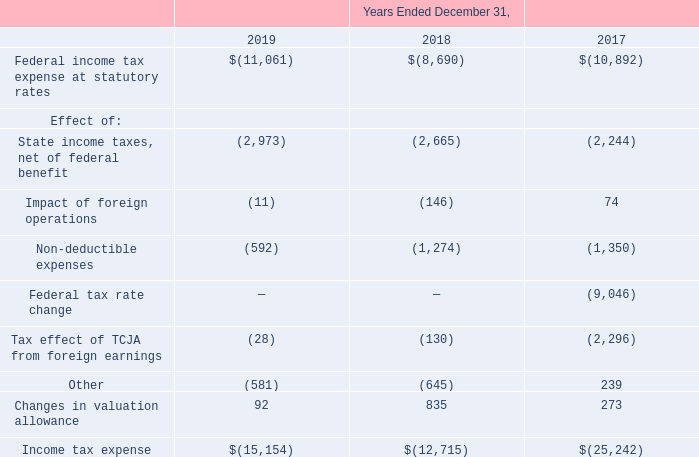5. Income taxes: (Continued)
In the normal course of business the Company takes positions on its tax returns that may be challenged by taxing
authorities. The Company evaluates all uncertain tax positions to assess whether the position will more likely than not
be sustained upon examination. If the Company determines that the tax position is not more likely than not to be
sustained, the Company records a liability for the amount of the benefit that is not more likely than not to be realized
when the tax position is settled. The Company does not have a liability for uncertain tax positions at December 31,
2019 and does not expect that its liability for uncertain tax positions will materially increase during the twelve months
ended December 31, 2020, however, actual changes in the liability for uncertain tax positions could be different than
currently expected. If recognized, changes in the Company's total unrecognized tax benefits would impact the
Company's effective income tax rate.
In the normal course of business the Company takes positions on its tax returns that may be challenged by taxing authorities. The Company evaluates all uncertain tax positions to assess whether the position will more likely than not be sustained upon examination. If the Company determines that the tax position is not more likely than not to be sustained, the Company records a liability for the amount of the benefit that is not more likely than not to be realized when the tax position is settled. The Company does not have a liability for uncertain tax positions at December 31, 2019 and does not expect that its liability for uncertain tax positions will materially increase during the twelve months ended December 31, 2020, however, actual changes in the liability for uncertain tax positions could be different than currently expected. If recognized, changes in the Company's total unrecognized tax benefits would impact the Company's effective income tax rate. In the normal course of business the Company takes positions on its tax returns that may be challenged by taxing authorities. The Company evaluates all uncertain tax positions to assess whether the position will more likely than not be sustained upon examination. If the Company determines that the tax position is not more likely than not to be sustained, the Company records a liability for the amount of the benefit that is not more likely than not to be realized when the tax position is settled. The Company does not have a liability for uncertain tax positions at December 31, 2019 and does not expect that its liability for uncertain tax positions will materially increase during the twelve months ended December 31, 2020, however, actual changes in the liability for uncertain tax positions could be different than currently expected. If recognized, changes in the Company's total unrecognized tax benefits would impact the Company's effective income tax rate. In the normal course of business the Company takes positions on its tax returns that may be challenged by taxing authorities. The Company evaluates all uncertain tax positions to assess whether the position will more likely than not be sustained upon examination. If the Company determines that the tax position is not more likely than not to be sustained, the Company records a liability for the amount of the benefit that is not more likely than not to be realized when the tax position is settled. The Company does not have a liability for uncertain tax positions at December 31, 2019 and does not expect that its liability for uncertain tax positions will materially increase during the twelve months ended December 31, 2020, however, actual changes in the liability for uncertain tax positions could be different than currently expected. If recognized, changes in the Company's total unrecognized tax benefits would impact the Company's effective income tax rate.
The Company or one of its subsidiaries files income tax returns in the US federal jurisdiction and various state and foreign jurisdictions. The Company is subject to US federal tax and state tax examinations for years 2004 to 2019. The Company is subject to tax examinations in its foreign jurisdictions generally for years 2005 to 2019.
The following is a reconciliation of the Federal statutory income taxes to the amounts reported in the financial statements (in thousands).
What are the respective federal income tax expense at statutory rates in 2017 and 2018?
Answer scale should be: thousand. 10,892, 8,690. What are the respective federal income tax expense at statutory rates in 2018 and 2019?
Answer scale should be: thousand. 8,690, 11,061. What are the respective state income taxes, net of federal benefit in 2017 and 2018?
Answer scale should be: thousand. 2,244, 2,665. What is the average federal income tax expense at statutory rates in 2017 and 2018?
Answer scale should be: thousand. (10,892 + 8,690)/2 
Answer: 9791. What is the average federal income tax expense at statutory rates in 2018 and 2019?
Answer scale should be: thousand. (8,690 + 11,061)/2 
Answer: 9875.5. What is the average state income taxes, net of federal benefit in 2017 and 2018?
Answer scale should be: thousand. (2,244 + 2,665)/2 
Answer: 2454.5. 